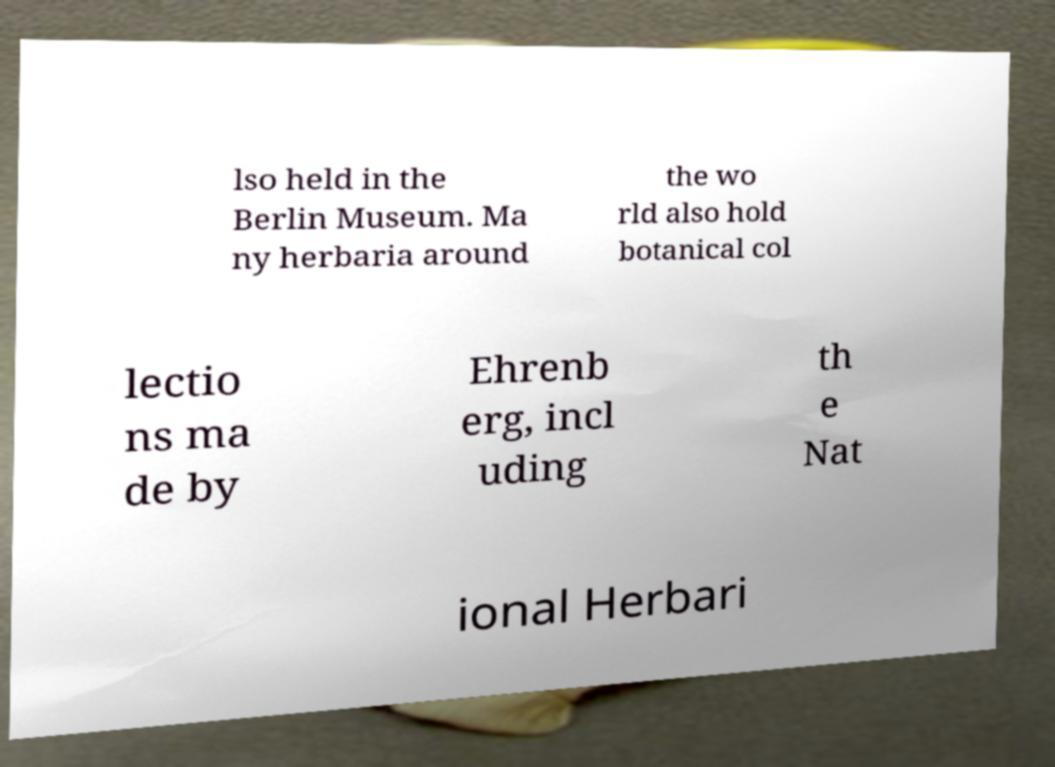Please read and relay the text visible in this image. What does it say? lso held in the Berlin Museum. Ma ny herbaria around the wo rld also hold botanical col lectio ns ma de by Ehrenb erg, incl uding th e Nat ional Herbari 